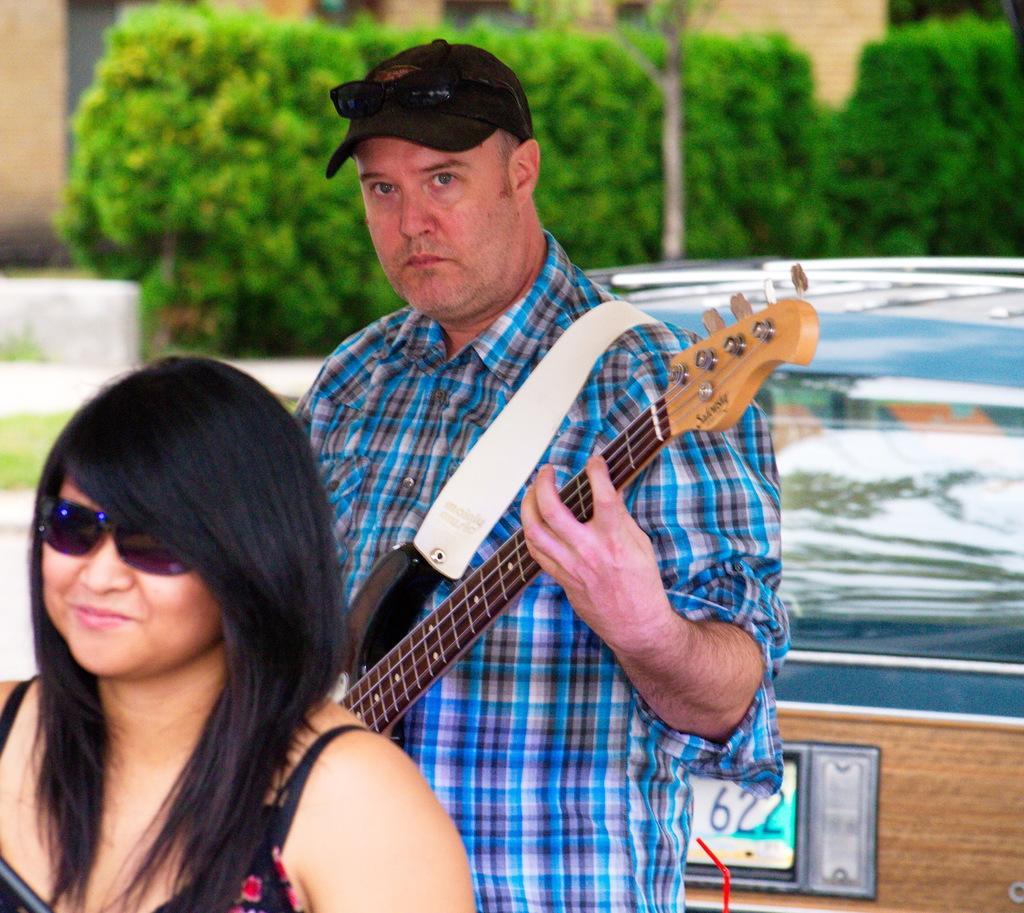In one or two sentences, can you explain what this image depicts? Here we can see a person standing and playing the guitar, and in front a woman is standing, and at back here are the trees. 